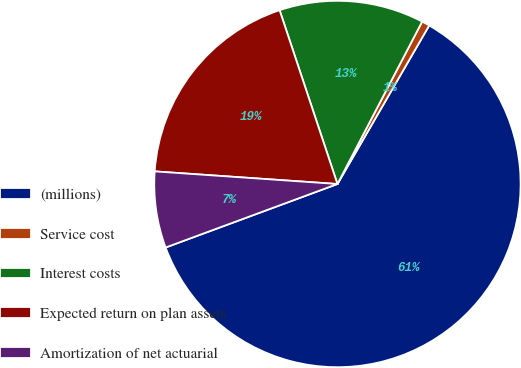Convert chart. <chart><loc_0><loc_0><loc_500><loc_500><pie_chart><fcel>(millions)<fcel>Service cost<fcel>Interest costs<fcel>Expected return on plan assets<fcel>Amortization of net actuarial<nl><fcel>61.01%<fcel>0.7%<fcel>12.76%<fcel>18.79%<fcel>6.73%<nl></chart> 